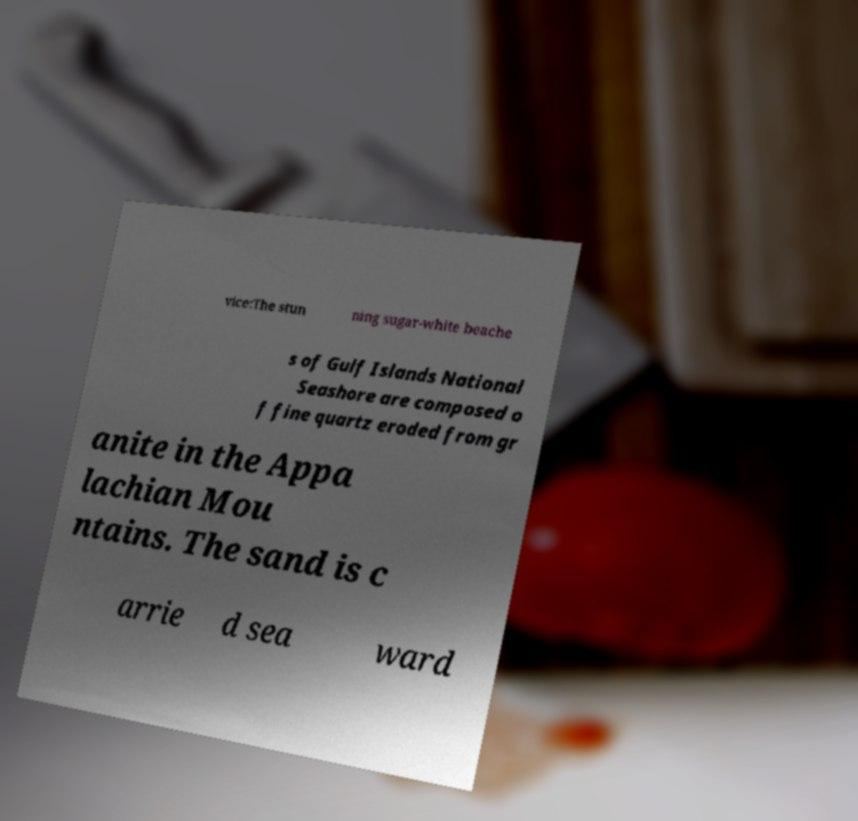I need the written content from this picture converted into text. Can you do that? vice:The stun ning sugar-white beache s of Gulf Islands National Seashore are composed o f fine quartz eroded from gr anite in the Appa lachian Mou ntains. The sand is c arrie d sea ward 